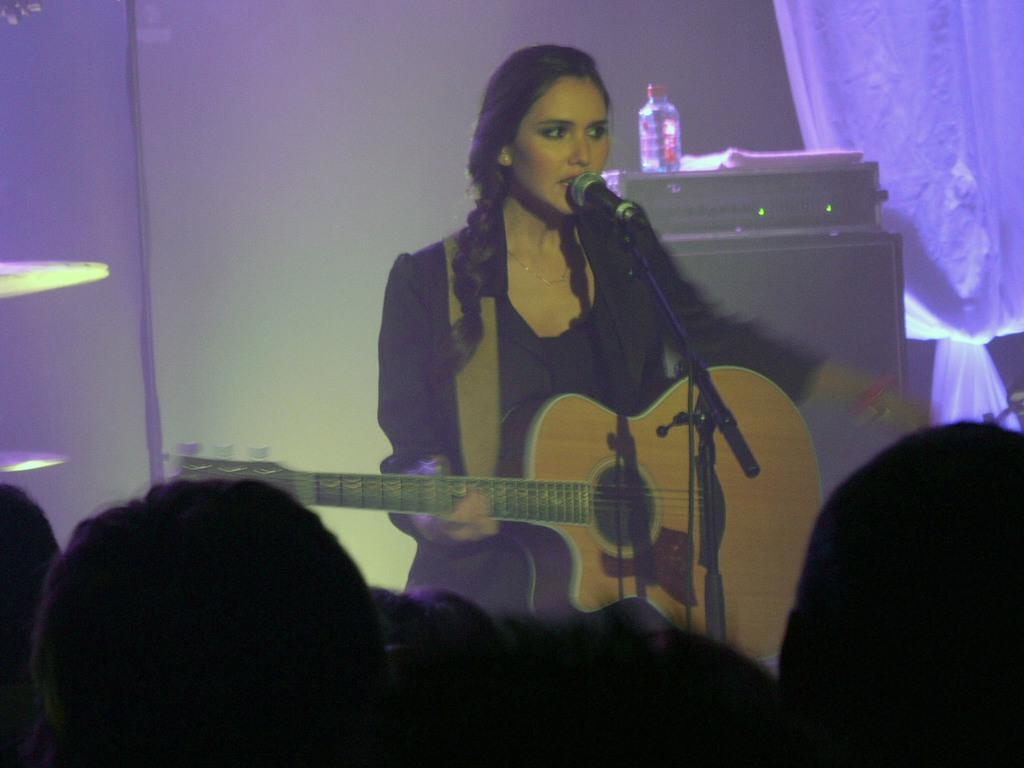Describe this image in one or two sentences. In this image I see a woman who is holding a guitar and she is in front of a mic. In the background I see an equipment on which there is a bottle and I see the curtain over here. 